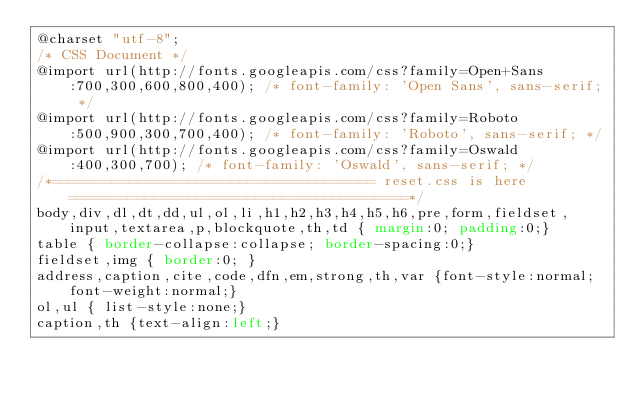<code> <loc_0><loc_0><loc_500><loc_500><_CSS_>@charset "utf-8";
/* CSS Document */
@import url(http://fonts.googleapis.com/css?family=Open+Sans:700,300,600,800,400); /* font-family: 'Open Sans', sans-serif; */
@import url(http://fonts.googleapis.com/css?family=Roboto:500,900,300,700,400); /* font-family: 'Roboto', sans-serif; */
@import url(http://fonts.googleapis.com/css?family=Oswald:400,300,700); /* font-family: 'Oswald', sans-serif; */
/*====================================== reset.css is here ========================================*/
body,div,dl,dt,dd,ul,ol,li,h1,h2,h3,h4,h5,h6,pre,form,fieldset,input,textarea,p,blockquote,th,td { margin:0; padding:0;}
table {	border-collapse:collapse; border-spacing:0;}
fieldset,img { border:0; }
address,caption,cite,code,dfn,em,strong,th,var {font-style:normal; font-weight:normal;}
ol,ul { list-style:none;}
caption,th {text-align:left;}</code> 